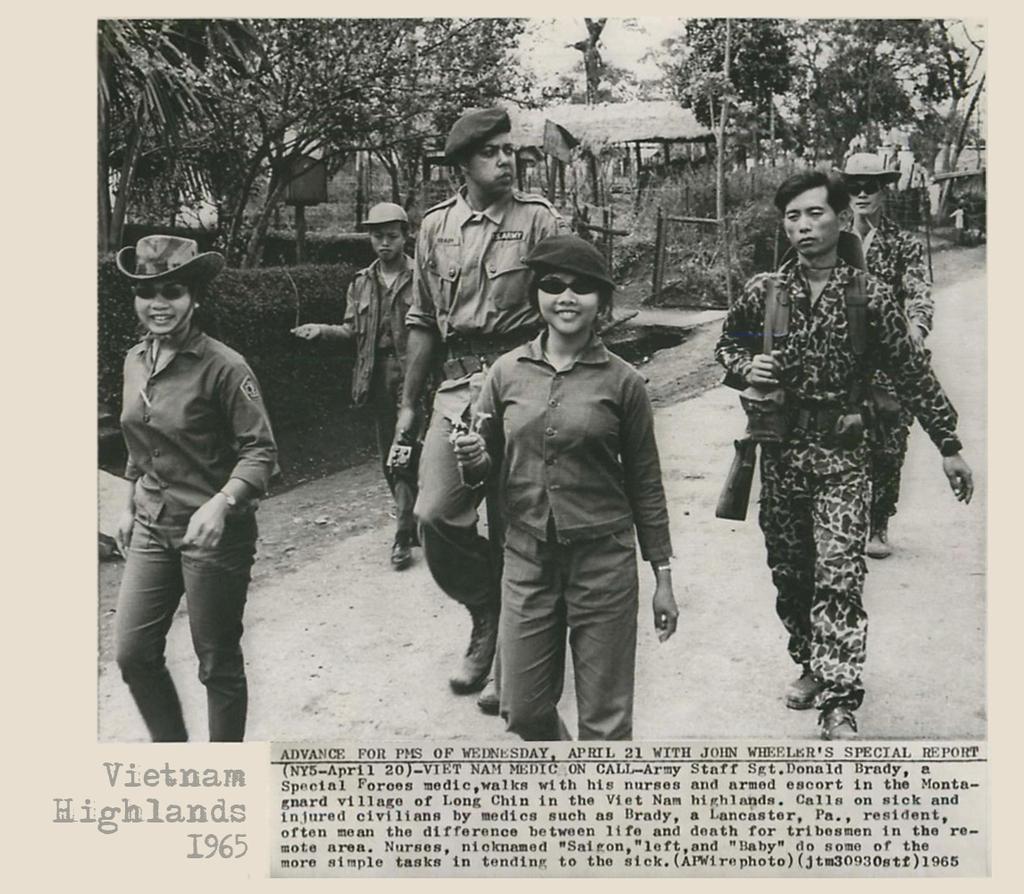Please provide a concise description of this image. Here people are walking, this is hat and gun, these are trees. 